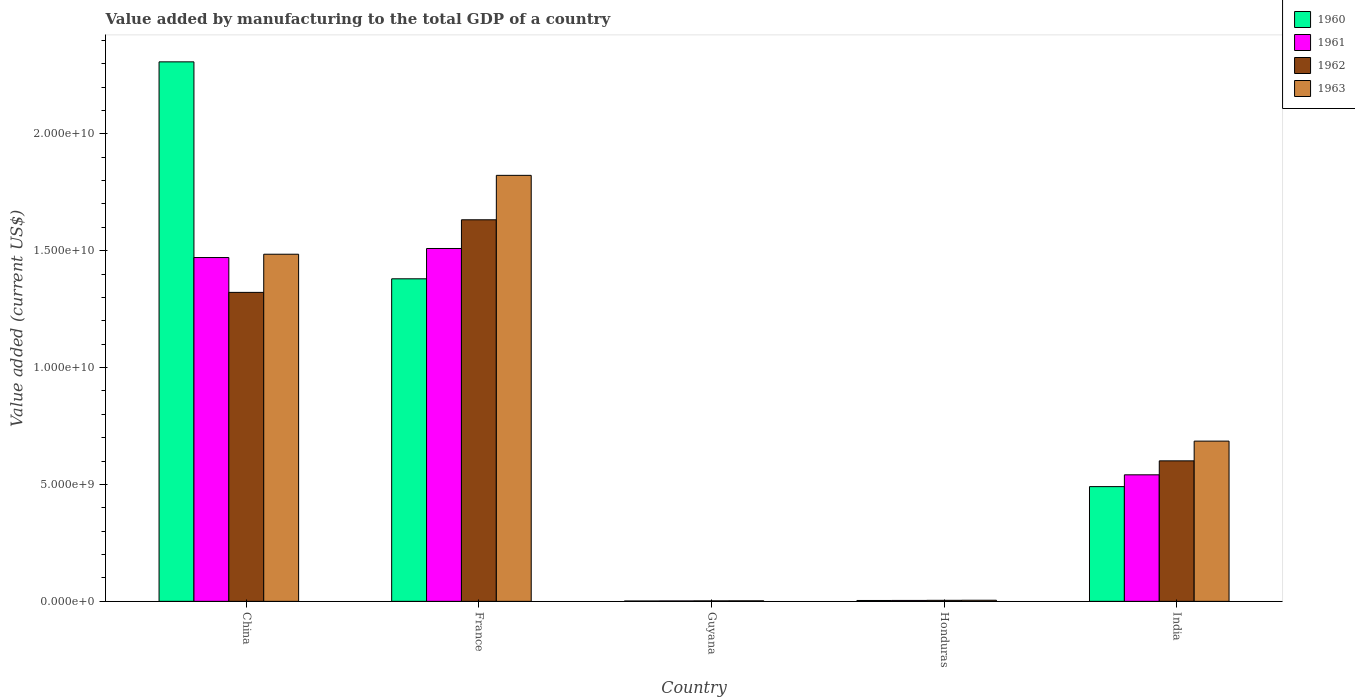Are the number of bars per tick equal to the number of legend labels?
Your answer should be compact. Yes. Are the number of bars on each tick of the X-axis equal?
Provide a succinct answer. Yes. How many bars are there on the 2nd tick from the left?
Your response must be concise. 4. What is the label of the 2nd group of bars from the left?
Keep it short and to the point. France. What is the value added by manufacturing to the total GDP in 1962 in China?
Offer a terse response. 1.32e+1. Across all countries, what is the maximum value added by manufacturing to the total GDP in 1961?
Ensure brevity in your answer.  1.51e+1. Across all countries, what is the minimum value added by manufacturing to the total GDP in 1961?
Keep it short and to the point. 1.84e+07. In which country was the value added by manufacturing to the total GDP in 1961 maximum?
Your answer should be very brief. France. In which country was the value added by manufacturing to the total GDP in 1963 minimum?
Offer a terse response. Guyana. What is the total value added by manufacturing to the total GDP in 1961 in the graph?
Offer a very short reply. 3.53e+1. What is the difference between the value added by manufacturing to the total GDP in 1961 in France and that in Guyana?
Provide a succinct answer. 1.51e+1. What is the difference between the value added by manufacturing to the total GDP in 1961 in Guyana and the value added by manufacturing to the total GDP in 1960 in China?
Your response must be concise. -2.31e+1. What is the average value added by manufacturing to the total GDP in 1961 per country?
Provide a short and direct response. 7.06e+09. What is the difference between the value added by manufacturing to the total GDP of/in 1960 and value added by manufacturing to the total GDP of/in 1961 in France?
Your answer should be very brief. -1.30e+09. What is the ratio of the value added by manufacturing to the total GDP in 1962 in France to that in Guyana?
Your answer should be very brief. 786.05. What is the difference between the highest and the second highest value added by manufacturing to the total GDP in 1961?
Offer a terse response. -3.87e+08. What is the difference between the highest and the lowest value added by manufacturing to the total GDP in 1962?
Your answer should be compact. 1.63e+1. In how many countries, is the value added by manufacturing to the total GDP in 1962 greater than the average value added by manufacturing to the total GDP in 1962 taken over all countries?
Your answer should be very brief. 2. Is the sum of the value added by manufacturing to the total GDP in 1961 in Guyana and Honduras greater than the maximum value added by manufacturing to the total GDP in 1963 across all countries?
Ensure brevity in your answer.  No. How many bars are there?
Give a very brief answer. 20. Are all the bars in the graph horizontal?
Offer a very short reply. No. Does the graph contain any zero values?
Provide a succinct answer. No. Does the graph contain grids?
Your answer should be compact. No. How are the legend labels stacked?
Provide a short and direct response. Vertical. What is the title of the graph?
Provide a short and direct response. Value added by manufacturing to the total GDP of a country. Does "1986" appear as one of the legend labels in the graph?
Your answer should be very brief. No. What is the label or title of the Y-axis?
Offer a terse response. Value added (current US$). What is the Value added (current US$) in 1960 in China?
Keep it short and to the point. 2.31e+1. What is the Value added (current US$) in 1961 in China?
Your answer should be very brief. 1.47e+1. What is the Value added (current US$) of 1962 in China?
Offer a very short reply. 1.32e+1. What is the Value added (current US$) in 1963 in China?
Provide a short and direct response. 1.49e+1. What is the Value added (current US$) of 1960 in France?
Give a very brief answer. 1.38e+1. What is the Value added (current US$) of 1961 in France?
Provide a short and direct response. 1.51e+1. What is the Value added (current US$) of 1962 in France?
Offer a very short reply. 1.63e+1. What is the Value added (current US$) in 1963 in France?
Offer a very short reply. 1.82e+1. What is the Value added (current US$) of 1960 in Guyana?
Provide a succinct answer. 1.59e+07. What is the Value added (current US$) in 1961 in Guyana?
Make the answer very short. 1.84e+07. What is the Value added (current US$) of 1962 in Guyana?
Give a very brief answer. 2.08e+07. What is the Value added (current US$) of 1963 in Guyana?
Ensure brevity in your answer.  2.32e+07. What is the Value added (current US$) of 1960 in Honduras?
Your answer should be compact. 3.80e+07. What is the Value added (current US$) of 1961 in Honduras?
Keep it short and to the point. 4.00e+07. What is the Value added (current US$) of 1962 in Honduras?
Offer a terse response. 4.41e+07. What is the Value added (current US$) of 1963 in Honduras?
Give a very brief answer. 4.76e+07. What is the Value added (current US$) in 1960 in India?
Offer a very short reply. 4.91e+09. What is the Value added (current US$) of 1961 in India?
Give a very brief answer. 5.41e+09. What is the Value added (current US$) in 1962 in India?
Offer a very short reply. 6.01e+09. What is the Value added (current US$) in 1963 in India?
Offer a very short reply. 6.85e+09. Across all countries, what is the maximum Value added (current US$) in 1960?
Your answer should be very brief. 2.31e+1. Across all countries, what is the maximum Value added (current US$) in 1961?
Your response must be concise. 1.51e+1. Across all countries, what is the maximum Value added (current US$) in 1962?
Provide a succinct answer. 1.63e+1. Across all countries, what is the maximum Value added (current US$) of 1963?
Your answer should be very brief. 1.82e+1. Across all countries, what is the minimum Value added (current US$) of 1960?
Keep it short and to the point. 1.59e+07. Across all countries, what is the minimum Value added (current US$) in 1961?
Your response must be concise. 1.84e+07. Across all countries, what is the minimum Value added (current US$) in 1962?
Make the answer very short. 2.08e+07. Across all countries, what is the minimum Value added (current US$) in 1963?
Offer a very short reply. 2.32e+07. What is the total Value added (current US$) in 1960 in the graph?
Provide a succinct answer. 4.18e+1. What is the total Value added (current US$) in 1961 in the graph?
Provide a succinct answer. 3.53e+1. What is the total Value added (current US$) in 1962 in the graph?
Provide a short and direct response. 3.56e+1. What is the total Value added (current US$) of 1963 in the graph?
Provide a succinct answer. 4.00e+1. What is the difference between the Value added (current US$) of 1960 in China and that in France?
Give a very brief answer. 9.28e+09. What is the difference between the Value added (current US$) in 1961 in China and that in France?
Your response must be concise. -3.87e+08. What is the difference between the Value added (current US$) in 1962 in China and that in France?
Offer a very short reply. -3.11e+09. What is the difference between the Value added (current US$) in 1963 in China and that in France?
Keep it short and to the point. -3.37e+09. What is the difference between the Value added (current US$) in 1960 in China and that in Guyana?
Provide a short and direct response. 2.31e+1. What is the difference between the Value added (current US$) in 1961 in China and that in Guyana?
Offer a terse response. 1.47e+1. What is the difference between the Value added (current US$) in 1962 in China and that in Guyana?
Offer a terse response. 1.32e+1. What is the difference between the Value added (current US$) in 1963 in China and that in Guyana?
Give a very brief answer. 1.48e+1. What is the difference between the Value added (current US$) of 1960 in China and that in Honduras?
Ensure brevity in your answer.  2.30e+1. What is the difference between the Value added (current US$) in 1961 in China and that in Honduras?
Your response must be concise. 1.47e+1. What is the difference between the Value added (current US$) of 1962 in China and that in Honduras?
Provide a short and direct response. 1.32e+1. What is the difference between the Value added (current US$) of 1963 in China and that in Honduras?
Provide a short and direct response. 1.48e+1. What is the difference between the Value added (current US$) in 1960 in China and that in India?
Keep it short and to the point. 1.82e+1. What is the difference between the Value added (current US$) of 1961 in China and that in India?
Make the answer very short. 9.30e+09. What is the difference between the Value added (current US$) of 1962 in China and that in India?
Your response must be concise. 7.21e+09. What is the difference between the Value added (current US$) of 1963 in China and that in India?
Your answer should be compact. 8.00e+09. What is the difference between the Value added (current US$) of 1960 in France and that in Guyana?
Your answer should be very brief. 1.38e+1. What is the difference between the Value added (current US$) of 1961 in France and that in Guyana?
Offer a very short reply. 1.51e+1. What is the difference between the Value added (current US$) of 1962 in France and that in Guyana?
Your answer should be compact. 1.63e+1. What is the difference between the Value added (current US$) in 1963 in France and that in Guyana?
Give a very brief answer. 1.82e+1. What is the difference between the Value added (current US$) in 1960 in France and that in Honduras?
Make the answer very short. 1.38e+1. What is the difference between the Value added (current US$) in 1961 in France and that in Honduras?
Offer a very short reply. 1.51e+1. What is the difference between the Value added (current US$) of 1962 in France and that in Honduras?
Keep it short and to the point. 1.63e+1. What is the difference between the Value added (current US$) in 1963 in France and that in Honduras?
Ensure brevity in your answer.  1.82e+1. What is the difference between the Value added (current US$) in 1960 in France and that in India?
Keep it short and to the point. 8.89e+09. What is the difference between the Value added (current US$) of 1961 in France and that in India?
Provide a short and direct response. 9.68e+09. What is the difference between the Value added (current US$) of 1962 in France and that in India?
Offer a terse response. 1.03e+1. What is the difference between the Value added (current US$) in 1963 in France and that in India?
Provide a succinct answer. 1.14e+1. What is the difference between the Value added (current US$) of 1960 in Guyana and that in Honduras?
Provide a succinct answer. -2.22e+07. What is the difference between the Value added (current US$) of 1961 in Guyana and that in Honduras?
Keep it short and to the point. -2.17e+07. What is the difference between the Value added (current US$) in 1962 in Guyana and that in Honduras?
Give a very brief answer. -2.33e+07. What is the difference between the Value added (current US$) in 1963 in Guyana and that in Honduras?
Provide a succinct answer. -2.44e+07. What is the difference between the Value added (current US$) of 1960 in Guyana and that in India?
Make the answer very short. -4.89e+09. What is the difference between the Value added (current US$) of 1961 in Guyana and that in India?
Offer a terse response. -5.40e+09. What is the difference between the Value added (current US$) in 1962 in Guyana and that in India?
Ensure brevity in your answer.  -5.99e+09. What is the difference between the Value added (current US$) of 1963 in Guyana and that in India?
Provide a succinct answer. -6.83e+09. What is the difference between the Value added (current US$) in 1960 in Honduras and that in India?
Your answer should be very brief. -4.87e+09. What is the difference between the Value added (current US$) in 1961 in Honduras and that in India?
Offer a terse response. -5.37e+09. What is the difference between the Value added (current US$) of 1962 in Honduras and that in India?
Your answer should be very brief. -5.97e+09. What is the difference between the Value added (current US$) of 1963 in Honduras and that in India?
Your answer should be very brief. -6.81e+09. What is the difference between the Value added (current US$) in 1960 in China and the Value added (current US$) in 1961 in France?
Make the answer very short. 7.98e+09. What is the difference between the Value added (current US$) in 1960 in China and the Value added (current US$) in 1962 in France?
Offer a very short reply. 6.76e+09. What is the difference between the Value added (current US$) in 1960 in China and the Value added (current US$) in 1963 in France?
Make the answer very short. 4.86e+09. What is the difference between the Value added (current US$) of 1961 in China and the Value added (current US$) of 1962 in France?
Your response must be concise. -1.61e+09. What is the difference between the Value added (current US$) of 1961 in China and the Value added (current US$) of 1963 in France?
Make the answer very short. -3.52e+09. What is the difference between the Value added (current US$) of 1962 in China and the Value added (current US$) of 1963 in France?
Offer a terse response. -5.01e+09. What is the difference between the Value added (current US$) of 1960 in China and the Value added (current US$) of 1961 in Guyana?
Your answer should be very brief. 2.31e+1. What is the difference between the Value added (current US$) in 1960 in China and the Value added (current US$) in 1962 in Guyana?
Your response must be concise. 2.31e+1. What is the difference between the Value added (current US$) of 1960 in China and the Value added (current US$) of 1963 in Guyana?
Offer a very short reply. 2.31e+1. What is the difference between the Value added (current US$) of 1961 in China and the Value added (current US$) of 1962 in Guyana?
Your answer should be compact. 1.47e+1. What is the difference between the Value added (current US$) of 1961 in China and the Value added (current US$) of 1963 in Guyana?
Provide a succinct answer. 1.47e+1. What is the difference between the Value added (current US$) of 1962 in China and the Value added (current US$) of 1963 in Guyana?
Offer a terse response. 1.32e+1. What is the difference between the Value added (current US$) of 1960 in China and the Value added (current US$) of 1961 in Honduras?
Your answer should be compact. 2.30e+1. What is the difference between the Value added (current US$) of 1960 in China and the Value added (current US$) of 1962 in Honduras?
Your answer should be compact. 2.30e+1. What is the difference between the Value added (current US$) in 1960 in China and the Value added (current US$) in 1963 in Honduras?
Give a very brief answer. 2.30e+1. What is the difference between the Value added (current US$) of 1961 in China and the Value added (current US$) of 1962 in Honduras?
Make the answer very short. 1.47e+1. What is the difference between the Value added (current US$) in 1961 in China and the Value added (current US$) in 1963 in Honduras?
Make the answer very short. 1.47e+1. What is the difference between the Value added (current US$) of 1962 in China and the Value added (current US$) of 1963 in Honduras?
Offer a terse response. 1.32e+1. What is the difference between the Value added (current US$) of 1960 in China and the Value added (current US$) of 1961 in India?
Your answer should be very brief. 1.77e+1. What is the difference between the Value added (current US$) of 1960 in China and the Value added (current US$) of 1962 in India?
Provide a short and direct response. 1.71e+1. What is the difference between the Value added (current US$) in 1960 in China and the Value added (current US$) in 1963 in India?
Provide a short and direct response. 1.62e+1. What is the difference between the Value added (current US$) of 1961 in China and the Value added (current US$) of 1962 in India?
Keep it short and to the point. 8.70e+09. What is the difference between the Value added (current US$) of 1961 in China and the Value added (current US$) of 1963 in India?
Make the answer very short. 7.85e+09. What is the difference between the Value added (current US$) of 1962 in China and the Value added (current US$) of 1963 in India?
Give a very brief answer. 6.36e+09. What is the difference between the Value added (current US$) of 1960 in France and the Value added (current US$) of 1961 in Guyana?
Give a very brief answer. 1.38e+1. What is the difference between the Value added (current US$) in 1960 in France and the Value added (current US$) in 1962 in Guyana?
Your response must be concise. 1.38e+1. What is the difference between the Value added (current US$) in 1960 in France and the Value added (current US$) in 1963 in Guyana?
Your answer should be compact. 1.38e+1. What is the difference between the Value added (current US$) in 1961 in France and the Value added (current US$) in 1962 in Guyana?
Ensure brevity in your answer.  1.51e+1. What is the difference between the Value added (current US$) of 1961 in France and the Value added (current US$) of 1963 in Guyana?
Offer a very short reply. 1.51e+1. What is the difference between the Value added (current US$) in 1962 in France and the Value added (current US$) in 1963 in Guyana?
Offer a terse response. 1.63e+1. What is the difference between the Value added (current US$) of 1960 in France and the Value added (current US$) of 1961 in Honduras?
Keep it short and to the point. 1.38e+1. What is the difference between the Value added (current US$) in 1960 in France and the Value added (current US$) in 1962 in Honduras?
Provide a short and direct response. 1.38e+1. What is the difference between the Value added (current US$) in 1960 in France and the Value added (current US$) in 1963 in Honduras?
Your answer should be very brief. 1.38e+1. What is the difference between the Value added (current US$) of 1961 in France and the Value added (current US$) of 1962 in Honduras?
Your response must be concise. 1.51e+1. What is the difference between the Value added (current US$) of 1961 in France and the Value added (current US$) of 1963 in Honduras?
Provide a succinct answer. 1.50e+1. What is the difference between the Value added (current US$) of 1962 in France and the Value added (current US$) of 1963 in Honduras?
Provide a succinct answer. 1.63e+1. What is the difference between the Value added (current US$) of 1960 in France and the Value added (current US$) of 1961 in India?
Your response must be concise. 8.39e+09. What is the difference between the Value added (current US$) in 1960 in France and the Value added (current US$) in 1962 in India?
Ensure brevity in your answer.  7.79e+09. What is the difference between the Value added (current US$) of 1960 in France and the Value added (current US$) of 1963 in India?
Keep it short and to the point. 6.94e+09. What is the difference between the Value added (current US$) in 1961 in France and the Value added (current US$) in 1962 in India?
Offer a terse response. 9.09e+09. What is the difference between the Value added (current US$) in 1961 in France and the Value added (current US$) in 1963 in India?
Make the answer very short. 8.24e+09. What is the difference between the Value added (current US$) in 1962 in France and the Value added (current US$) in 1963 in India?
Your answer should be very brief. 9.47e+09. What is the difference between the Value added (current US$) in 1960 in Guyana and the Value added (current US$) in 1961 in Honduras?
Provide a succinct answer. -2.42e+07. What is the difference between the Value added (current US$) in 1960 in Guyana and the Value added (current US$) in 1962 in Honduras?
Offer a terse response. -2.82e+07. What is the difference between the Value added (current US$) in 1960 in Guyana and the Value added (current US$) in 1963 in Honduras?
Provide a short and direct response. -3.17e+07. What is the difference between the Value added (current US$) of 1961 in Guyana and the Value added (current US$) of 1962 in Honduras?
Give a very brief answer. -2.57e+07. What is the difference between the Value added (current US$) of 1961 in Guyana and the Value added (current US$) of 1963 in Honduras?
Your answer should be very brief. -2.92e+07. What is the difference between the Value added (current US$) of 1962 in Guyana and the Value added (current US$) of 1963 in Honduras?
Offer a very short reply. -2.68e+07. What is the difference between the Value added (current US$) in 1960 in Guyana and the Value added (current US$) in 1961 in India?
Give a very brief answer. -5.40e+09. What is the difference between the Value added (current US$) of 1960 in Guyana and the Value added (current US$) of 1962 in India?
Offer a terse response. -5.99e+09. What is the difference between the Value added (current US$) in 1960 in Guyana and the Value added (current US$) in 1963 in India?
Give a very brief answer. -6.84e+09. What is the difference between the Value added (current US$) in 1961 in Guyana and the Value added (current US$) in 1962 in India?
Ensure brevity in your answer.  -5.99e+09. What is the difference between the Value added (current US$) in 1961 in Guyana and the Value added (current US$) in 1963 in India?
Provide a short and direct response. -6.84e+09. What is the difference between the Value added (current US$) in 1962 in Guyana and the Value added (current US$) in 1963 in India?
Offer a very short reply. -6.83e+09. What is the difference between the Value added (current US$) in 1960 in Honduras and the Value added (current US$) in 1961 in India?
Offer a terse response. -5.38e+09. What is the difference between the Value added (current US$) of 1960 in Honduras and the Value added (current US$) of 1962 in India?
Your answer should be very brief. -5.97e+09. What is the difference between the Value added (current US$) of 1960 in Honduras and the Value added (current US$) of 1963 in India?
Offer a very short reply. -6.82e+09. What is the difference between the Value added (current US$) in 1961 in Honduras and the Value added (current US$) in 1962 in India?
Provide a short and direct response. -5.97e+09. What is the difference between the Value added (current US$) in 1961 in Honduras and the Value added (current US$) in 1963 in India?
Provide a succinct answer. -6.81e+09. What is the difference between the Value added (current US$) in 1962 in Honduras and the Value added (current US$) in 1963 in India?
Your answer should be compact. -6.81e+09. What is the average Value added (current US$) in 1960 per country?
Keep it short and to the point. 8.37e+09. What is the average Value added (current US$) of 1961 per country?
Offer a terse response. 7.06e+09. What is the average Value added (current US$) in 1962 per country?
Your response must be concise. 7.12e+09. What is the average Value added (current US$) in 1963 per country?
Make the answer very short. 8.00e+09. What is the difference between the Value added (current US$) of 1960 and Value added (current US$) of 1961 in China?
Offer a very short reply. 8.37e+09. What is the difference between the Value added (current US$) in 1960 and Value added (current US$) in 1962 in China?
Provide a short and direct response. 9.86e+09. What is the difference between the Value added (current US$) in 1960 and Value added (current US$) in 1963 in China?
Offer a very short reply. 8.23e+09. What is the difference between the Value added (current US$) of 1961 and Value added (current US$) of 1962 in China?
Offer a terse response. 1.49e+09. What is the difference between the Value added (current US$) in 1961 and Value added (current US$) in 1963 in China?
Your answer should be very brief. -1.42e+08. What is the difference between the Value added (current US$) in 1962 and Value added (current US$) in 1963 in China?
Offer a very short reply. -1.63e+09. What is the difference between the Value added (current US$) in 1960 and Value added (current US$) in 1961 in France?
Your answer should be very brief. -1.30e+09. What is the difference between the Value added (current US$) of 1960 and Value added (current US$) of 1962 in France?
Your answer should be compact. -2.52e+09. What is the difference between the Value added (current US$) of 1960 and Value added (current US$) of 1963 in France?
Ensure brevity in your answer.  -4.43e+09. What is the difference between the Value added (current US$) in 1961 and Value added (current US$) in 1962 in France?
Your answer should be compact. -1.23e+09. What is the difference between the Value added (current US$) in 1961 and Value added (current US$) in 1963 in France?
Offer a terse response. -3.13e+09. What is the difference between the Value added (current US$) of 1962 and Value added (current US$) of 1963 in France?
Offer a terse response. -1.90e+09. What is the difference between the Value added (current US$) in 1960 and Value added (current US$) in 1961 in Guyana?
Offer a very short reply. -2.51e+06. What is the difference between the Value added (current US$) in 1960 and Value added (current US$) in 1962 in Guyana?
Ensure brevity in your answer.  -4.90e+06. What is the difference between the Value added (current US$) in 1960 and Value added (current US$) in 1963 in Guyana?
Ensure brevity in your answer.  -7.29e+06. What is the difference between the Value added (current US$) of 1961 and Value added (current US$) of 1962 in Guyana?
Make the answer very short. -2.39e+06. What is the difference between the Value added (current US$) in 1961 and Value added (current US$) in 1963 in Guyana?
Your response must be concise. -4.78e+06. What is the difference between the Value added (current US$) of 1962 and Value added (current US$) of 1963 in Guyana?
Provide a succinct answer. -2.39e+06. What is the difference between the Value added (current US$) of 1960 and Value added (current US$) of 1961 in Honduras?
Your answer should be compact. -2.00e+06. What is the difference between the Value added (current US$) of 1960 and Value added (current US$) of 1962 in Honduras?
Your answer should be compact. -6.05e+06. What is the difference between the Value added (current US$) in 1960 and Value added (current US$) in 1963 in Honduras?
Give a very brief answer. -9.50e+06. What is the difference between the Value added (current US$) in 1961 and Value added (current US$) in 1962 in Honduras?
Ensure brevity in your answer.  -4.05e+06. What is the difference between the Value added (current US$) of 1961 and Value added (current US$) of 1963 in Honduras?
Provide a short and direct response. -7.50e+06. What is the difference between the Value added (current US$) of 1962 and Value added (current US$) of 1963 in Honduras?
Make the answer very short. -3.45e+06. What is the difference between the Value added (current US$) of 1960 and Value added (current US$) of 1961 in India?
Your response must be concise. -5.05e+08. What is the difference between the Value added (current US$) in 1960 and Value added (current US$) in 1962 in India?
Keep it short and to the point. -1.10e+09. What is the difference between the Value added (current US$) in 1960 and Value added (current US$) in 1963 in India?
Ensure brevity in your answer.  -1.95e+09. What is the difference between the Value added (current US$) in 1961 and Value added (current US$) in 1962 in India?
Give a very brief answer. -5.97e+08. What is the difference between the Value added (current US$) in 1961 and Value added (current US$) in 1963 in India?
Keep it short and to the point. -1.44e+09. What is the difference between the Value added (current US$) in 1962 and Value added (current US$) in 1963 in India?
Offer a terse response. -8.44e+08. What is the ratio of the Value added (current US$) of 1960 in China to that in France?
Provide a succinct answer. 1.67. What is the ratio of the Value added (current US$) of 1961 in China to that in France?
Your answer should be compact. 0.97. What is the ratio of the Value added (current US$) in 1962 in China to that in France?
Give a very brief answer. 0.81. What is the ratio of the Value added (current US$) of 1963 in China to that in France?
Your response must be concise. 0.81. What is the ratio of the Value added (current US$) of 1960 in China to that in Guyana?
Provide a succinct answer. 1454.66. What is the ratio of the Value added (current US$) of 1961 in China to that in Guyana?
Provide a succinct answer. 800.48. What is the ratio of the Value added (current US$) in 1962 in China to that in Guyana?
Provide a succinct answer. 636.5. What is the ratio of the Value added (current US$) of 1963 in China to that in Guyana?
Provide a short and direct response. 641.28. What is the ratio of the Value added (current US$) of 1960 in China to that in Honduras?
Give a very brief answer. 606.59. What is the ratio of the Value added (current US$) of 1961 in China to that in Honduras?
Keep it short and to the point. 367.26. What is the ratio of the Value added (current US$) in 1962 in China to that in Honduras?
Give a very brief answer. 299.73. What is the ratio of the Value added (current US$) in 1963 in China to that in Honduras?
Keep it short and to the point. 312.32. What is the ratio of the Value added (current US$) of 1960 in China to that in India?
Ensure brevity in your answer.  4.7. What is the ratio of the Value added (current US$) in 1961 in China to that in India?
Your answer should be very brief. 2.72. What is the ratio of the Value added (current US$) of 1962 in China to that in India?
Give a very brief answer. 2.2. What is the ratio of the Value added (current US$) in 1963 in China to that in India?
Ensure brevity in your answer.  2.17. What is the ratio of the Value added (current US$) in 1960 in France to that in Guyana?
Your answer should be compact. 869.7. What is the ratio of the Value added (current US$) of 1961 in France to that in Guyana?
Your answer should be compact. 821.55. What is the ratio of the Value added (current US$) in 1962 in France to that in Guyana?
Make the answer very short. 786.05. What is the ratio of the Value added (current US$) in 1963 in France to that in Guyana?
Your response must be concise. 786.97. What is the ratio of the Value added (current US$) of 1960 in France to that in Honduras?
Your response must be concise. 362.66. What is the ratio of the Value added (current US$) of 1961 in France to that in Honduras?
Offer a terse response. 376.93. What is the ratio of the Value added (current US$) in 1962 in France to that in Honduras?
Provide a short and direct response. 370.15. What is the ratio of the Value added (current US$) of 1963 in France to that in Honduras?
Give a very brief answer. 383.28. What is the ratio of the Value added (current US$) of 1960 in France to that in India?
Your response must be concise. 2.81. What is the ratio of the Value added (current US$) of 1961 in France to that in India?
Offer a terse response. 2.79. What is the ratio of the Value added (current US$) in 1962 in France to that in India?
Offer a terse response. 2.72. What is the ratio of the Value added (current US$) of 1963 in France to that in India?
Keep it short and to the point. 2.66. What is the ratio of the Value added (current US$) of 1960 in Guyana to that in Honduras?
Your answer should be compact. 0.42. What is the ratio of the Value added (current US$) of 1961 in Guyana to that in Honduras?
Offer a very short reply. 0.46. What is the ratio of the Value added (current US$) of 1962 in Guyana to that in Honduras?
Ensure brevity in your answer.  0.47. What is the ratio of the Value added (current US$) in 1963 in Guyana to that in Honduras?
Your answer should be very brief. 0.49. What is the ratio of the Value added (current US$) of 1960 in Guyana to that in India?
Offer a very short reply. 0. What is the ratio of the Value added (current US$) in 1961 in Guyana to that in India?
Provide a succinct answer. 0. What is the ratio of the Value added (current US$) of 1962 in Guyana to that in India?
Give a very brief answer. 0. What is the ratio of the Value added (current US$) of 1963 in Guyana to that in India?
Offer a very short reply. 0. What is the ratio of the Value added (current US$) in 1960 in Honduras to that in India?
Offer a terse response. 0.01. What is the ratio of the Value added (current US$) in 1961 in Honduras to that in India?
Provide a short and direct response. 0.01. What is the ratio of the Value added (current US$) of 1962 in Honduras to that in India?
Offer a very short reply. 0.01. What is the ratio of the Value added (current US$) in 1963 in Honduras to that in India?
Offer a terse response. 0.01. What is the difference between the highest and the second highest Value added (current US$) in 1960?
Your answer should be compact. 9.28e+09. What is the difference between the highest and the second highest Value added (current US$) in 1961?
Make the answer very short. 3.87e+08. What is the difference between the highest and the second highest Value added (current US$) in 1962?
Keep it short and to the point. 3.11e+09. What is the difference between the highest and the second highest Value added (current US$) of 1963?
Your answer should be compact. 3.37e+09. What is the difference between the highest and the lowest Value added (current US$) in 1960?
Your answer should be compact. 2.31e+1. What is the difference between the highest and the lowest Value added (current US$) of 1961?
Keep it short and to the point. 1.51e+1. What is the difference between the highest and the lowest Value added (current US$) of 1962?
Provide a succinct answer. 1.63e+1. What is the difference between the highest and the lowest Value added (current US$) in 1963?
Keep it short and to the point. 1.82e+1. 